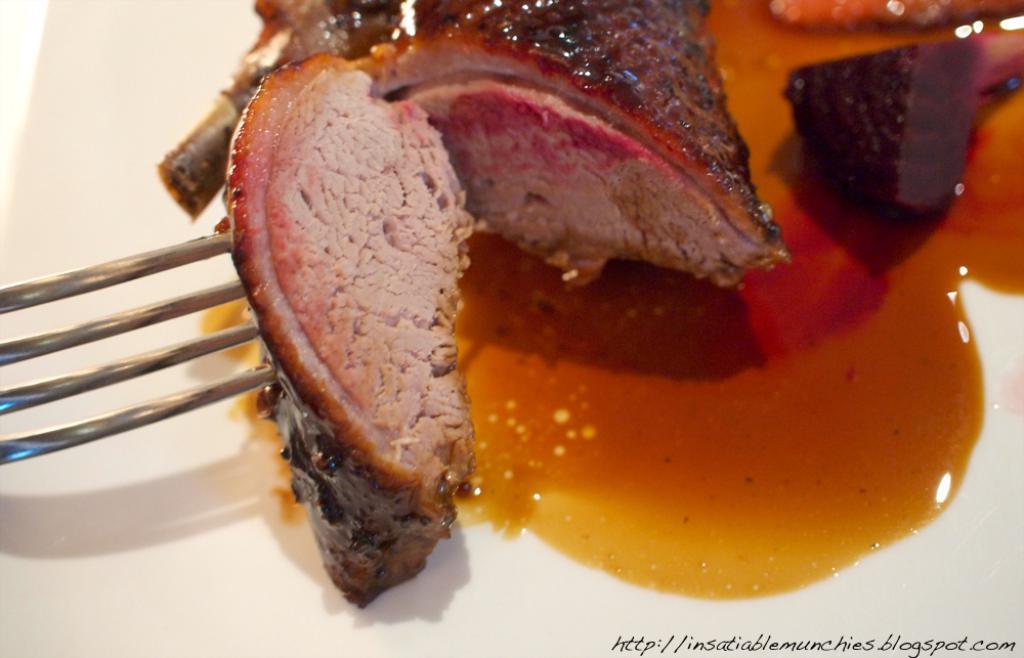Can you describe this image briefly? In this picture there is food item served in a plate. On the left it is fork. At the bottom towards right it is text. 